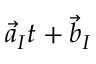Convert formula to latex. <formula><loc_0><loc_0><loc_500><loc_500>\vec { a } _ { I } t + \vec { b } _ { I }</formula> 